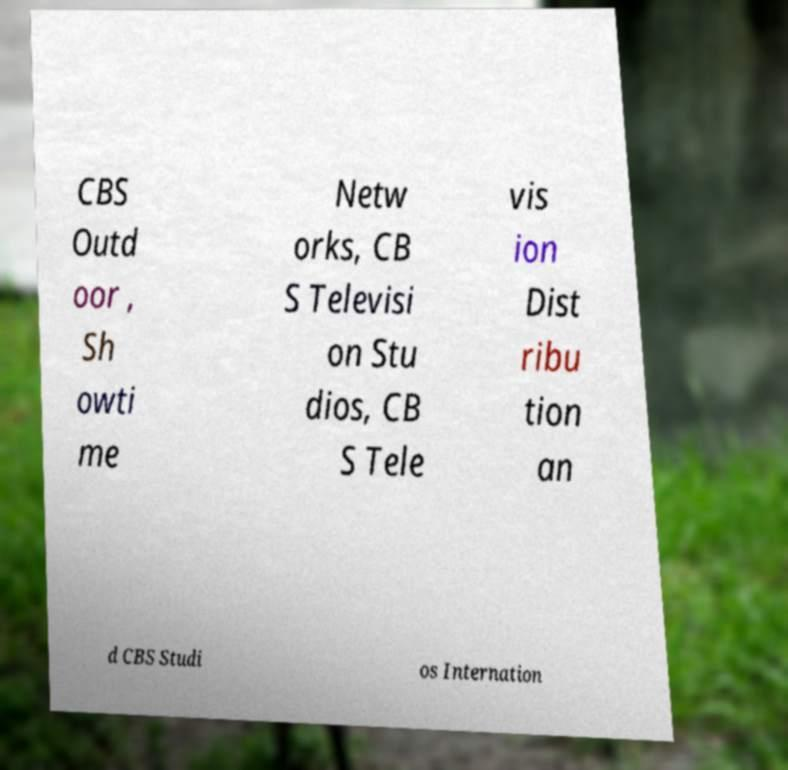Can you read and provide the text displayed in the image?This photo seems to have some interesting text. Can you extract and type it out for me? CBS Outd oor , Sh owti me Netw orks, CB S Televisi on Stu dios, CB S Tele vis ion Dist ribu tion an d CBS Studi os Internation 